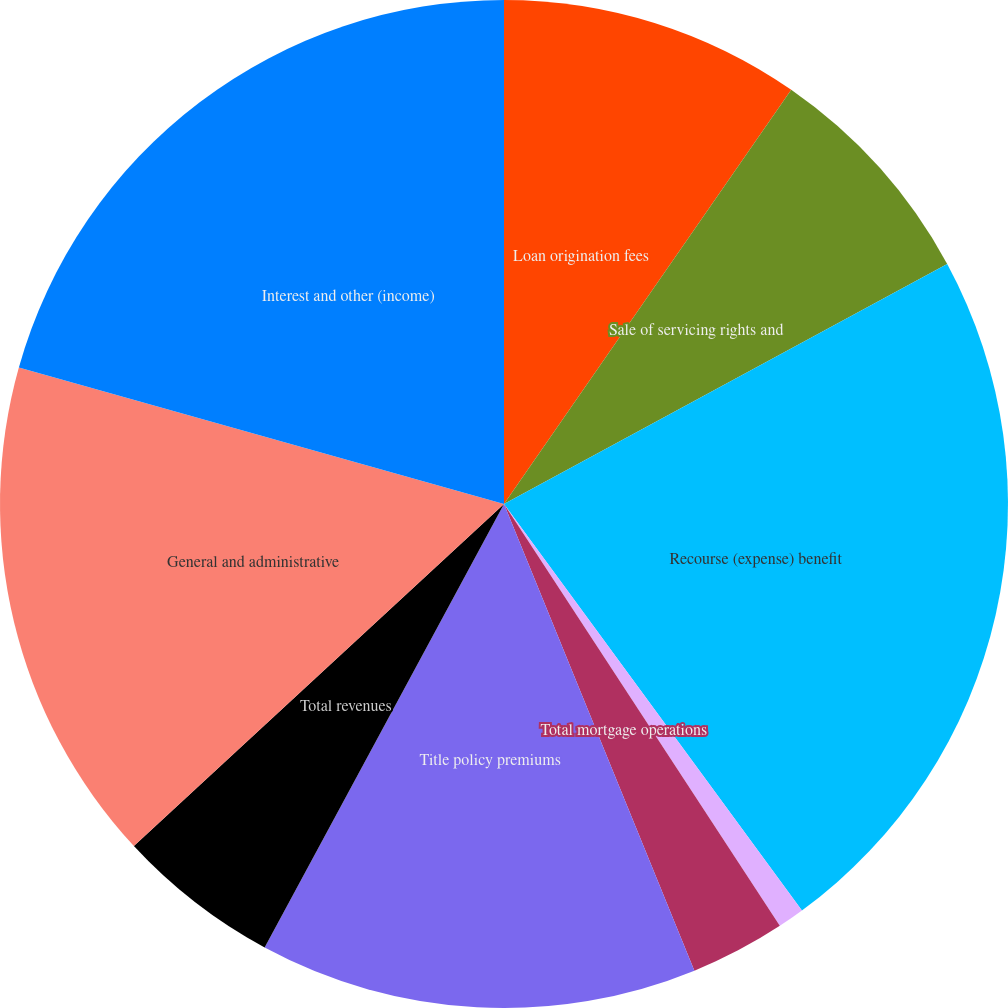Convert chart to OTSL. <chart><loc_0><loc_0><loc_500><loc_500><pie_chart><fcel>Loan origination fees<fcel>Sale of servicing rights and<fcel>Recourse (expense) benefit<fcel>Other revenues<fcel>Total mortgage operations<fcel>Title policy premiums<fcel>Total revenues<fcel>General and administrative<fcel>Interest and other (income)<nl><fcel>9.65%<fcel>7.45%<fcel>22.83%<fcel>0.85%<fcel>3.05%<fcel>14.04%<fcel>5.25%<fcel>16.24%<fcel>20.63%<nl></chart> 